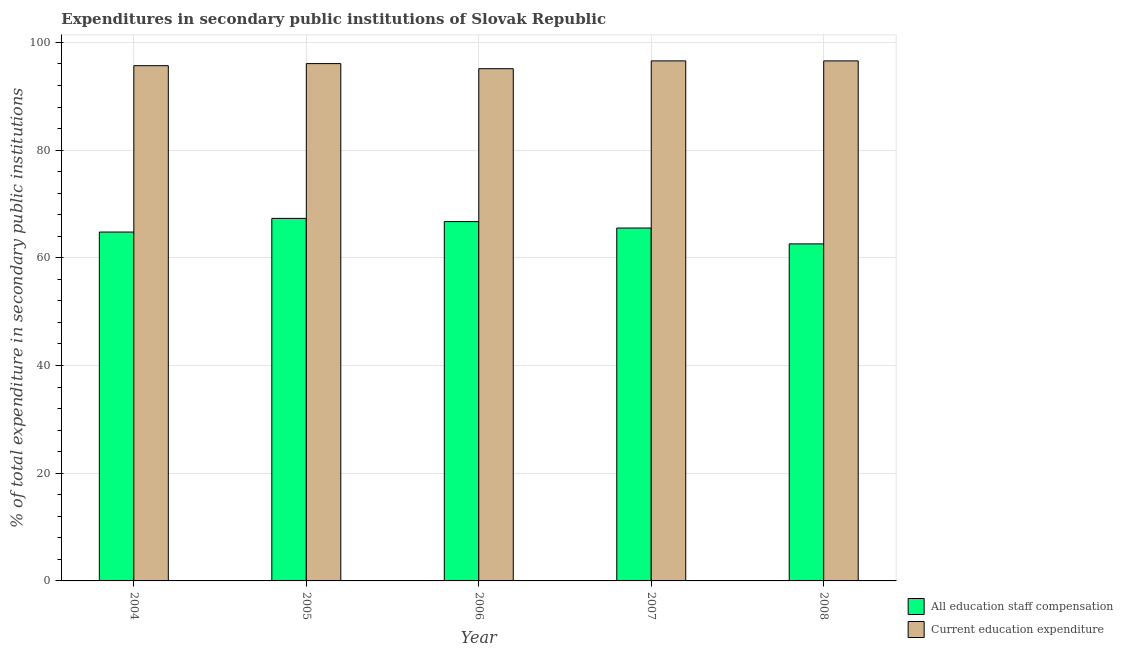How many groups of bars are there?
Make the answer very short. 5. How many bars are there on the 3rd tick from the left?
Provide a short and direct response. 2. How many bars are there on the 1st tick from the right?
Your answer should be very brief. 2. What is the expenditure in education in 2007?
Your answer should be very brief. 96.57. Across all years, what is the maximum expenditure in education?
Your response must be concise. 96.57. Across all years, what is the minimum expenditure in staff compensation?
Make the answer very short. 62.59. What is the total expenditure in education in the graph?
Offer a very short reply. 480.01. What is the difference between the expenditure in education in 2004 and that in 2008?
Your response must be concise. -0.89. What is the difference between the expenditure in education in 2008 and the expenditure in staff compensation in 2004?
Offer a very short reply. 0.89. What is the average expenditure in staff compensation per year?
Your answer should be very brief. 65.39. In the year 2008, what is the difference between the expenditure in staff compensation and expenditure in education?
Your answer should be very brief. 0. In how many years, is the expenditure in staff compensation greater than 24 %?
Provide a succinct answer. 5. What is the ratio of the expenditure in staff compensation in 2007 to that in 2008?
Provide a succinct answer. 1.05. What is the difference between the highest and the second highest expenditure in education?
Offer a very short reply. 0. What is the difference between the highest and the lowest expenditure in staff compensation?
Give a very brief answer. 4.73. Is the sum of the expenditure in staff compensation in 2004 and 2008 greater than the maximum expenditure in education across all years?
Make the answer very short. Yes. What does the 2nd bar from the left in 2007 represents?
Offer a terse response. Current education expenditure. What does the 2nd bar from the right in 2004 represents?
Your answer should be very brief. All education staff compensation. Are all the bars in the graph horizontal?
Provide a short and direct response. No. How many legend labels are there?
Offer a very short reply. 2. What is the title of the graph?
Keep it short and to the point. Expenditures in secondary public institutions of Slovak Republic. Does "Working capital" appear as one of the legend labels in the graph?
Give a very brief answer. No. What is the label or title of the X-axis?
Your response must be concise. Year. What is the label or title of the Y-axis?
Ensure brevity in your answer.  % of total expenditure in secondary public institutions. What is the % of total expenditure in secondary public institutions in All education staff compensation in 2004?
Your answer should be compact. 64.79. What is the % of total expenditure in secondary public institutions of Current education expenditure in 2004?
Provide a short and direct response. 95.68. What is the % of total expenditure in secondary public institutions in All education staff compensation in 2005?
Provide a short and direct response. 67.32. What is the % of total expenditure in secondary public institutions in Current education expenditure in 2005?
Your response must be concise. 96.07. What is the % of total expenditure in secondary public institutions of All education staff compensation in 2006?
Provide a short and direct response. 66.73. What is the % of total expenditure in secondary public institutions of Current education expenditure in 2006?
Your response must be concise. 95.12. What is the % of total expenditure in secondary public institutions of All education staff compensation in 2007?
Offer a very short reply. 65.53. What is the % of total expenditure in secondary public institutions of Current education expenditure in 2007?
Provide a succinct answer. 96.57. What is the % of total expenditure in secondary public institutions in All education staff compensation in 2008?
Ensure brevity in your answer.  62.59. What is the % of total expenditure in secondary public institutions of Current education expenditure in 2008?
Provide a short and direct response. 96.57. Across all years, what is the maximum % of total expenditure in secondary public institutions of All education staff compensation?
Your answer should be very brief. 67.32. Across all years, what is the maximum % of total expenditure in secondary public institutions of Current education expenditure?
Make the answer very short. 96.57. Across all years, what is the minimum % of total expenditure in secondary public institutions of All education staff compensation?
Provide a succinct answer. 62.59. Across all years, what is the minimum % of total expenditure in secondary public institutions of Current education expenditure?
Ensure brevity in your answer.  95.12. What is the total % of total expenditure in secondary public institutions in All education staff compensation in the graph?
Your answer should be compact. 326.96. What is the total % of total expenditure in secondary public institutions in Current education expenditure in the graph?
Your answer should be compact. 480.01. What is the difference between the % of total expenditure in secondary public institutions of All education staff compensation in 2004 and that in 2005?
Your answer should be very brief. -2.53. What is the difference between the % of total expenditure in secondary public institutions in Current education expenditure in 2004 and that in 2005?
Provide a short and direct response. -0.39. What is the difference between the % of total expenditure in secondary public institutions of All education staff compensation in 2004 and that in 2006?
Offer a very short reply. -1.94. What is the difference between the % of total expenditure in secondary public institutions in Current education expenditure in 2004 and that in 2006?
Provide a succinct answer. 0.56. What is the difference between the % of total expenditure in secondary public institutions in All education staff compensation in 2004 and that in 2007?
Offer a very short reply. -0.75. What is the difference between the % of total expenditure in secondary public institutions of Current education expenditure in 2004 and that in 2007?
Your answer should be very brief. -0.89. What is the difference between the % of total expenditure in secondary public institutions of All education staff compensation in 2004 and that in 2008?
Your response must be concise. 2.2. What is the difference between the % of total expenditure in secondary public institutions of Current education expenditure in 2004 and that in 2008?
Your answer should be compact. -0.89. What is the difference between the % of total expenditure in secondary public institutions in All education staff compensation in 2005 and that in 2006?
Your answer should be compact. 0.59. What is the difference between the % of total expenditure in secondary public institutions in Current education expenditure in 2005 and that in 2006?
Provide a short and direct response. 0.94. What is the difference between the % of total expenditure in secondary public institutions of All education staff compensation in 2005 and that in 2007?
Ensure brevity in your answer.  1.79. What is the difference between the % of total expenditure in secondary public institutions of Current education expenditure in 2005 and that in 2007?
Give a very brief answer. -0.51. What is the difference between the % of total expenditure in secondary public institutions in All education staff compensation in 2005 and that in 2008?
Make the answer very short. 4.73. What is the difference between the % of total expenditure in secondary public institutions of Current education expenditure in 2005 and that in 2008?
Provide a short and direct response. -0.5. What is the difference between the % of total expenditure in secondary public institutions of All education staff compensation in 2006 and that in 2007?
Your response must be concise. 1.19. What is the difference between the % of total expenditure in secondary public institutions in Current education expenditure in 2006 and that in 2007?
Provide a succinct answer. -1.45. What is the difference between the % of total expenditure in secondary public institutions of All education staff compensation in 2006 and that in 2008?
Make the answer very short. 4.14. What is the difference between the % of total expenditure in secondary public institutions in Current education expenditure in 2006 and that in 2008?
Your answer should be very brief. -1.45. What is the difference between the % of total expenditure in secondary public institutions of All education staff compensation in 2007 and that in 2008?
Your response must be concise. 2.95. What is the difference between the % of total expenditure in secondary public institutions of Current education expenditure in 2007 and that in 2008?
Give a very brief answer. 0. What is the difference between the % of total expenditure in secondary public institutions in All education staff compensation in 2004 and the % of total expenditure in secondary public institutions in Current education expenditure in 2005?
Offer a terse response. -31.28. What is the difference between the % of total expenditure in secondary public institutions in All education staff compensation in 2004 and the % of total expenditure in secondary public institutions in Current education expenditure in 2006?
Your answer should be compact. -30.33. What is the difference between the % of total expenditure in secondary public institutions in All education staff compensation in 2004 and the % of total expenditure in secondary public institutions in Current education expenditure in 2007?
Your answer should be compact. -31.78. What is the difference between the % of total expenditure in secondary public institutions of All education staff compensation in 2004 and the % of total expenditure in secondary public institutions of Current education expenditure in 2008?
Your response must be concise. -31.78. What is the difference between the % of total expenditure in secondary public institutions in All education staff compensation in 2005 and the % of total expenditure in secondary public institutions in Current education expenditure in 2006?
Your response must be concise. -27.8. What is the difference between the % of total expenditure in secondary public institutions of All education staff compensation in 2005 and the % of total expenditure in secondary public institutions of Current education expenditure in 2007?
Your answer should be very brief. -29.25. What is the difference between the % of total expenditure in secondary public institutions of All education staff compensation in 2005 and the % of total expenditure in secondary public institutions of Current education expenditure in 2008?
Make the answer very short. -29.25. What is the difference between the % of total expenditure in secondary public institutions of All education staff compensation in 2006 and the % of total expenditure in secondary public institutions of Current education expenditure in 2007?
Your answer should be compact. -29.84. What is the difference between the % of total expenditure in secondary public institutions of All education staff compensation in 2006 and the % of total expenditure in secondary public institutions of Current education expenditure in 2008?
Make the answer very short. -29.84. What is the difference between the % of total expenditure in secondary public institutions in All education staff compensation in 2007 and the % of total expenditure in secondary public institutions in Current education expenditure in 2008?
Offer a terse response. -31.03. What is the average % of total expenditure in secondary public institutions of All education staff compensation per year?
Provide a short and direct response. 65.39. What is the average % of total expenditure in secondary public institutions in Current education expenditure per year?
Make the answer very short. 96. In the year 2004, what is the difference between the % of total expenditure in secondary public institutions in All education staff compensation and % of total expenditure in secondary public institutions in Current education expenditure?
Your answer should be very brief. -30.89. In the year 2005, what is the difference between the % of total expenditure in secondary public institutions of All education staff compensation and % of total expenditure in secondary public institutions of Current education expenditure?
Ensure brevity in your answer.  -28.74. In the year 2006, what is the difference between the % of total expenditure in secondary public institutions of All education staff compensation and % of total expenditure in secondary public institutions of Current education expenditure?
Ensure brevity in your answer.  -28.39. In the year 2007, what is the difference between the % of total expenditure in secondary public institutions of All education staff compensation and % of total expenditure in secondary public institutions of Current education expenditure?
Offer a terse response. -31.04. In the year 2008, what is the difference between the % of total expenditure in secondary public institutions in All education staff compensation and % of total expenditure in secondary public institutions in Current education expenditure?
Give a very brief answer. -33.98. What is the ratio of the % of total expenditure in secondary public institutions in All education staff compensation in 2004 to that in 2005?
Ensure brevity in your answer.  0.96. What is the ratio of the % of total expenditure in secondary public institutions in Current education expenditure in 2004 to that in 2005?
Your answer should be very brief. 1. What is the ratio of the % of total expenditure in secondary public institutions of All education staff compensation in 2004 to that in 2006?
Offer a very short reply. 0.97. What is the ratio of the % of total expenditure in secondary public institutions of All education staff compensation in 2004 to that in 2008?
Ensure brevity in your answer.  1.04. What is the ratio of the % of total expenditure in secondary public institutions of All education staff compensation in 2005 to that in 2006?
Your answer should be compact. 1.01. What is the ratio of the % of total expenditure in secondary public institutions of Current education expenditure in 2005 to that in 2006?
Offer a terse response. 1.01. What is the ratio of the % of total expenditure in secondary public institutions in All education staff compensation in 2005 to that in 2007?
Offer a terse response. 1.03. What is the ratio of the % of total expenditure in secondary public institutions of All education staff compensation in 2005 to that in 2008?
Your answer should be compact. 1.08. What is the ratio of the % of total expenditure in secondary public institutions in Current education expenditure in 2005 to that in 2008?
Provide a succinct answer. 0.99. What is the ratio of the % of total expenditure in secondary public institutions of All education staff compensation in 2006 to that in 2007?
Make the answer very short. 1.02. What is the ratio of the % of total expenditure in secondary public institutions in All education staff compensation in 2006 to that in 2008?
Provide a short and direct response. 1.07. What is the ratio of the % of total expenditure in secondary public institutions in Current education expenditure in 2006 to that in 2008?
Make the answer very short. 0.98. What is the ratio of the % of total expenditure in secondary public institutions of All education staff compensation in 2007 to that in 2008?
Your response must be concise. 1.05. What is the ratio of the % of total expenditure in secondary public institutions in Current education expenditure in 2007 to that in 2008?
Offer a very short reply. 1. What is the difference between the highest and the second highest % of total expenditure in secondary public institutions of All education staff compensation?
Make the answer very short. 0.59. What is the difference between the highest and the second highest % of total expenditure in secondary public institutions in Current education expenditure?
Give a very brief answer. 0. What is the difference between the highest and the lowest % of total expenditure in secondary public institutions of All education staff compensation?
Provide a short and direct response. 4.73. What is the difference between the highest and the lowest % of total expenditure in secondary public institutions in Current education expenditure?
Your answer should be compact. 1.45. 